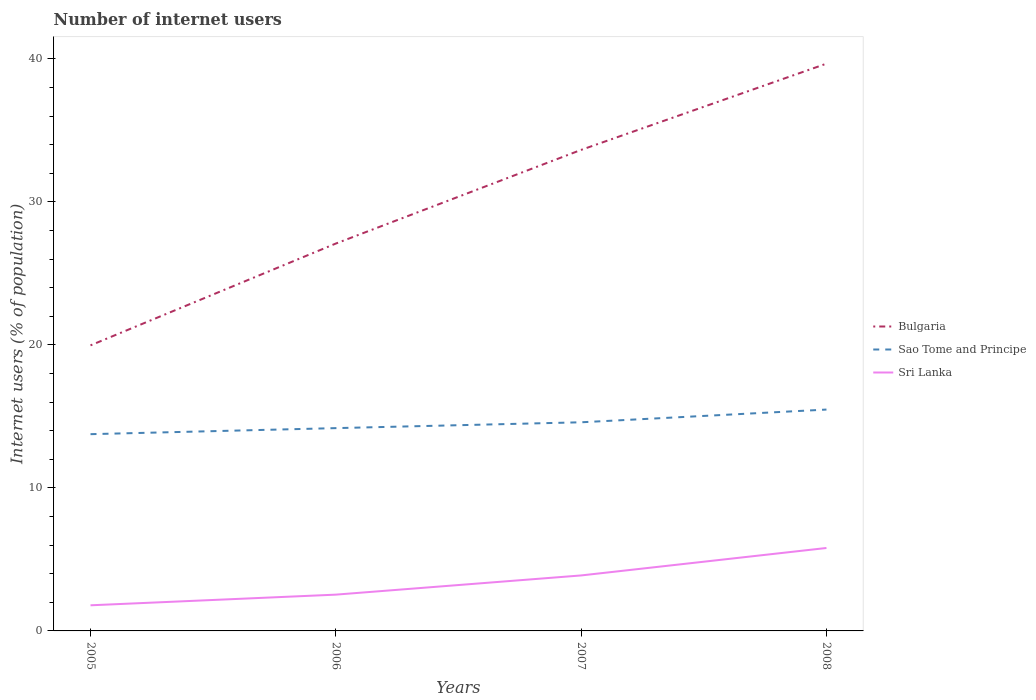How many different coloured lines are there?
Your answer should be compact. 3. Across all years, what is the maximum number of internet users in Sri Lanka?
Offer a very short reply. 1.79. In which year was the number of internet users in Sri Lanka maximum?
Your answer should be very brief. 2005. What is the total number of internet users in Sri Lanka in the graph?
Your answer should be compact. -2.09. What is the difference between the highest and the second highest number of internet users in Sri Lanka?
Give a very brief answer. 4.01. What is the difference between two consecutive major ticks on the Y-axis?
Your answer should be compact. 10. Does the graph contain any zero values?
Keep it short and to the point. No. Where does the legend appear in the graph?
Provide a short and direct response. Center right. How many legend labels are there?
Offer a terse response. 3. What is the title of the graph?
Offer a terse response. Number of internet users. Does "Puerto Rico" appear as one of the legend labels in the graph?
Ensure brevity in your answer.  No. What is the label or title of the X-axis?
Your answer should be compact. Years. What is the label or title of the Y-axis?
Keep it short and to the point. Internet users (% of population). What is the Internet users (% of population) in Bulgaria in 2005?
Your answer should be very brief. 19.97. What is the Internet users (% of population) of Sao Tome and Principe in 2005?
Offer a terse response. 13.76. What is the Internet users (% of population) of Sri Lanka in 2005?
Your answer should be compact. 1.79. What is the Internet users (% of population) in Bulgaria in 2006?
Make the answer very short. 27.09. What is the Internet users (% of population) of Sao Tome and Principe in 2006?
Provide a succinct answer. 14.18. What is the Internet users (% of population) of Sri Lanka in 2006?
Offer a very short reply. 2.54. What is the Internet users (% of population) in Bulgaria in 2007?
Your answer should be compact. 33.64. What is the Internet users (% of population) of Sao Tome and Principe in 2007?
Your response must be concise. 14.59. What is the Internet users (% of population) in Sri Lanka in 2007?
Provide a succinct answer. 3.88. What is the Internet users (% of population) in Bulgaria in 2008?
Offer a very short reply. 39.67. What is the Internet users (% of population) of Sao Tome and Principe in 2008?
Offer a terse response. 15.48. What is the Internet users (% of population) of Sri Lanka in 2008?
Offer a very short reply. 5.8. Across all years, what is the maximum Internet users (% of population) in Bulgaria?
Give a very brief answer. 39.67. Across all years, what is the maximum Internet users (% of population) in Sao Tome and Principe?
Make the answer very short. 15.48. Across all years, what is the minimum Internet users (% of population) of Bulgaria?
Provide a short and direct response. 19.97. Across all years, what is the minimum Internet users (% of population) in Sao Tome and Principe?
Offer a very short reply. 13.76. Across all years, what is the minimum Internet users (% of population) of Sri Lanka?
Your answer should be very brief. 1.79. What is the total Internet users (% of population) in Bulgaria in the graph?
Make the answer very short. 120.37. What is the total Internet users (% of population) of Sao Tome and Principe in the graph?
Offer a very short reply. 58.01. What is the total Internet users (% of population) of Sri Lanka in the graph?
Make the answer very short. 14.01. What is the difference between the Internet users (% of population) of Bulgaria in 2005 and that in 2006?
Ensure brevity in your answer.  -7.12. What is the difference between the Internet users (% of population) in Sao Tome and Principe in 2005 and that in 2006?
Your response must be concise. -0.42. What is the difference between the Internet users (% of population) of Sri Lanka in 2005 and that in 2006?
Offer a very short reply. -0.75. What is the difference between the Internet users (% of population) in Bulgaria in 2005 and that in 2007?
Keep it short and to the point. -13.67. What is the difference between the Internet users (% of population) of Sao Tome and Principe in 2005 and that in 2007?
Your answer should be very brief. -0.83. What is the difference between the Internet users (% of population) of Sri Lanka in 2005 and that in 2007?
Offer a very short reply. -2.09. What is the difference between the Internet users (% of population) of Bulgaria in 2005 and that in 2008?
Keep it short and to the point. -19.7. What is the difference between the Internet users (% of population) in Sao Tome and Principe in 2005 and that in 2008?
Give a very brief answer. -1.72. What is the difference between the Internet users (% of population) of Sri Lanka in 2005 and that in 2008?
Provide a short and direct response. -4.01. What is the difference between the Internet users (% of population) of Bulgaria in 2006 and that in 2007?
Provide a short and direct response. -6.55. What is the difference between the Internet users (% of population) of Sao Tome and Principe in 2006 and that in 2007?
Offer a terse response. -0.41. What is the difference between the Internet users (% of population) of Sri Lanka in 2006 and that in 2007?
Keep it short and to the point. -1.34. What is the difference between the Internet users (% of population) of Bulgaria in 2006 and that in 2008?
Offer a very short reply. -12.58. What is the difference between the Internet users (% of population) of Sao Tome and Principe in 2006 and that in 2008?
Your answer should be compact. -1.3. What is the difference between the Internet users (% of population) of Sri Lanka in 2006 and that in 2008?
Your answer should be very brief. -3.26. What is the difference between the Internet users (% of population) in Bulgaria in 2007 and that in 2008?
Your answer should be compact. -6.03. What is the difference between the Internet users (% of population) of Sao Tome and Principe in 2007 and that in 2008?
Provide a succinct answer. -0.89. What is the difference between the Internet users (% of population) of Sri Lanka in 2007 and that in 2008?
Provide a short and direct response. -1.92. What is the difference between the Internet users (% of population) in Bulgaria in 2005 and the Internet users (% of population) in Sao Tome and Principe in 2006?
Give a very brief answer. 5.79. What is the difference between the Internet users (% of population) in Bulgaria in 2005 and the Internet users (% of population) in Sri Lanka in 2006?
Offer a terse response. 17.43. What is the difference between the Internet users (% of population) in Sao Tome and Principe in 2005 and the Internet users (% of population) in Sri Lanka in 2006?
Keep it short and to the point. 11.22. What is the difference between the Internet users (% of population) of Bulgaria in 2005 and the Internet users (% of population) of Sao Tome and Principe in 2007?
Provide a succinct answer. 5.38. What is the difference between the Internet users (% of population) of Bulgaria in 2005 and the Internet users (% of population) of Sri Lanka in 2007?
Keep it short and to the point. 16.09. What is the difference between the Internet users (% of population) of Sao Tome and Principe in 2005 and the Internet users (% of population) of Sri Lanka in 2007?
Your response must be concise. 9.88. What is the difference between the Internet users (% of population) of Bulgaria in 2005 and the Internet users (% of population) of Sao Tome and Principe in 2008?
Make the answer very short. 4.49. What is the difference between the Internet users (% of population) of Bulgaria in 2005 and the Internet users (% of population) of Sri Lanka in 2008?
Make the answer very short. 14.17. What is the difference between the Internet users (% of population) of Sao Tome and Principe in 2005 and the Internet users (% of population) of Sri Lanka in 2008?
Your answer should be very brief. 7.96. What is the difference between the Internet users (% of population) of Bulgaria in 2006 and the Internet users (% of population) of Sao Tome and Principe in 2007?
Your answer should be compact. 12.5. What is the difference between the Internet users (% of population) in Bulgaria in 2006 and the Internet users (% of population) in Sri Lanka in 2007?
Offer a very short reply. 23.21. What is the difference between the Internet users (% of population) in Sao Tome and Principe in 2006 and the Internet users (% of population) in Sri Lanka in 2007?
Your answer should be very brief. 10.3. What is the difference between the Internet users (% of population) of Bulgaria in 2006 and the Internet users (% of population) of Sao Tome and Principe in 2008?
Offer a very short reply. 11.61. What is the difference between the Internet users (% of population) in Bulgaria in 2006 and the Internet users (% of population) in Sri Lanka in 2008?
Offer a very short reply. 21.29. What is the difference between the Internet users (% of population) of Sao Tome and Principe in 2006 and the Internet users (% of population) of Sri Lanka in 2008?
Provide a short and direct response. 8.38. What is the difference between the Internet users (% of population) of Bulgaria in 2007 and the Internet users (% of population) of Sao Tome and Principe in 2008?
Offer a terse response. 18.16. What is the difference between the Internet users (% of population) in Bulgaria in 2007 and the Internet users (% of population) in Sri Lanka in 2008?
Offer a very short reply. 27.84. What is the difference between the Internet users (% of population) in Sao Tome and Principe in 2007 and the Internet users (% of population) in Sri Lanka in 2008?
Your response must be concise. 8.79. What is the average Internet users (% of population) in Bulgaria per year?
Offer a very short reply. 30.09. What is the average Internet users (% of population) in Sao Tome and Principe per year?
Your answer should be very brief. 14.5. What is the average Internet users (% of population) of Sri Lanka per year?
Give a very brief answer. 3.5. In the year 2005, what is the difference between the Internet users (% of population) in Bulgaria and Internet users (% of population) in Sao Tome and Principe?
Offer a very short reply. 6.21. In the year 2005, what is the difference between the Internet users (% of population) in Bulgaria and Internet users (% of population) in Sri Lanka?
Ensure brevity in your answer.  18.18. In the year 2005, what is the difference between the Internet users (% of population) of Sao Tome and Principe and Internet users (% of population) of Sri Lanka?
Offer a terse response. 11.97. In the year 2006, what is the difference between the Internet users (% of population) of Bulgaria and Internet users (% of population) of Sao Tome and Principe?
Offer a terse response. 12.91. In the year 2006, what is the difference between the Internet users (% of population) in Bulgaria and Internet users (% of population) in Sri Lanka?
Your response must be concise. 24.55. In the year 2006, what is the difference between the Internet users (% of population) in Sao Tome and Principe and Internet users (% of population) in Sri Lanka?
Provide a succinct answer. 11.64. In the year 2007, what is the difference between the Internet users (% of population) in Bulgaria and Internet users (% of population) in Sao Tome and Principe?
Make the answer very short. 19.05. In the year 2007, what is the difference between the Internet users (% of population) of Bulgaria and Internet users (% of population) of Sri Lanka?
Offer a very short reply. 29.76. In the year 2007, what is the difference between the Internet users (% of population) in Sao Tome and Principe and Internet users (% of population) in Sri Lanka?
Your answer should be very brief. 10.71. In the year 2008, what is the difference between the Internet users (% of population) of Bulgaria and Internet users (% of population) of Sao Tome and Principe?
Make the answer very short. 24.19. In the year 2008, what is the difference between the Internet users (% of population) of Bulgaria and Internet users (% of population) of Sri Lanka?
Provide a succinct answer. 33.87. In the year 2008, what is the difference between the Internet users (% of population) in Sao Tome and Principe and Internet users (% of population) in Sri Lanka?
Keep it short and to the point. 9.68. What is the ratio of the Internet users (% of population) of Bulgaria in 2005 to that in 2006?
Provide a short and direct response. 0.74. What is the ratio of the Internet users (% of population) in Sao Tome and Principe in 2005 to that in 2006?
Your response must be concise. 0.97. What is the ratio of the Internet users (% of population) in Sri Lanka in 2005 to that in 2006?
Give a very brief answer. 0.71. What is the ratio of the Internet users (% of population) in Bulgaria in 2005 to that in 2007?
Give a very brief answer. 0.59. What is the ratio of the Internet users (% of population) of Sao Tome and Principe in 2005 to that in 2007?
Your response must be concise. 0.94. What is the ratio of the Internet users (% of population) of Sri Lanka in 2005 to that in 2007?
Make the answer very short. 0.46. What is the ratio of the Internet users (% of population) of Bulgaria in 2005 to that in 2008?
Your answer should be compact. 0.5. What is the ratio of the Internet users (% of population) in Sao Tome and Principe in 2005 to that in 2008?
Your response must be concise. 0.89. What is the ratio of the Internet users (% of population) in Sri Lanka in 2005 to that in 2008?
Ensure brevity in your answer.  0.31. What is the ratio of the Internet users (% of population) of Bulgaria in 2006 to that in 2007?
Offer a very short reply. 0.81. What is the ratio of the Internet users (% of population) of Sao Tome and Principe in 2006 to that in 2007?
Your answer should be compact. 0.97. What is the ratio of the Internet users (% of population) of Sri Lanka in 2006 to that in 2007?
Ensure brevity in your answer.  0.65. What is the ratio of the Internet users (% of population) of Bulgaria in 2006 to that in 2008?
Offer a terse response. 0.68. What is the ratio of the Internet users (% of population) of Sao Tome and Principe in 2006 to that in 2008?
Give a very brief answer. 0.92. What is the ratio of the Internet users (% of population) of Sri Lanka in 2006 to that in 2008?
Ensure brevity in your answer.  0.44. What is the ratio of the Internet users (% of population) of Bulgaria in 2007 to that in 2008?
Your answer should be very brief. 0.85. What is the ratio of the Internet users (% of population) in Sao Tome and Principe in 2007 to that in 2008?
Give a very brief answer. 0.94. What is the ratio of the Internet users (% of population) in Sri Lanka in 2007 to that in 2008?
Offer a very short reply. 0.67. What is the difference between the highest and the second highest Internet users (% of population) in Bulgaria?
Offer a terse response. 6.03. What is the difference between the highest and the second highest Internet users (% of population) of Sao Tome and Principe?
Offer a very short reply. 0.89. What is the difference between the highest and the second highest Internet users (% of population) in Sri Lanka?
Your answer should be very brief. 1.92. What is the difference between the highest and the lowest Internet users (% of population) in Sao Tome and Principe?
Ensure brevity in your answer.  1.72. What is the difference between the highest and the lowest Internet users (% of population) of Sri Lanka?
Provide a succinct answer. 4.01. 